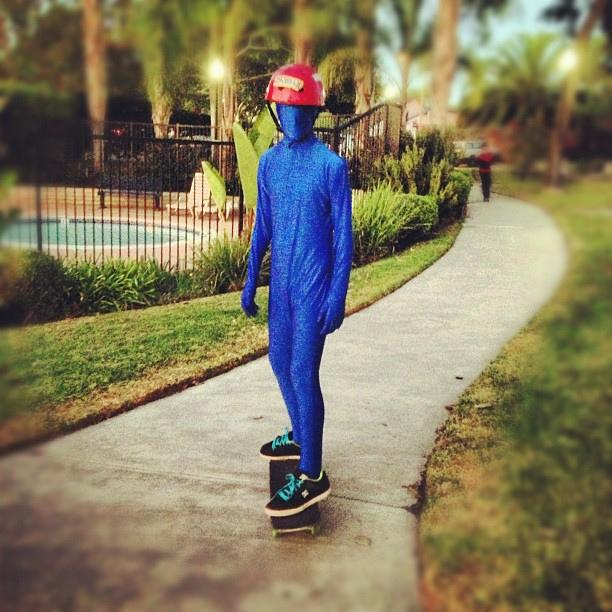What important property does this blue outfit have? aerodynamic 